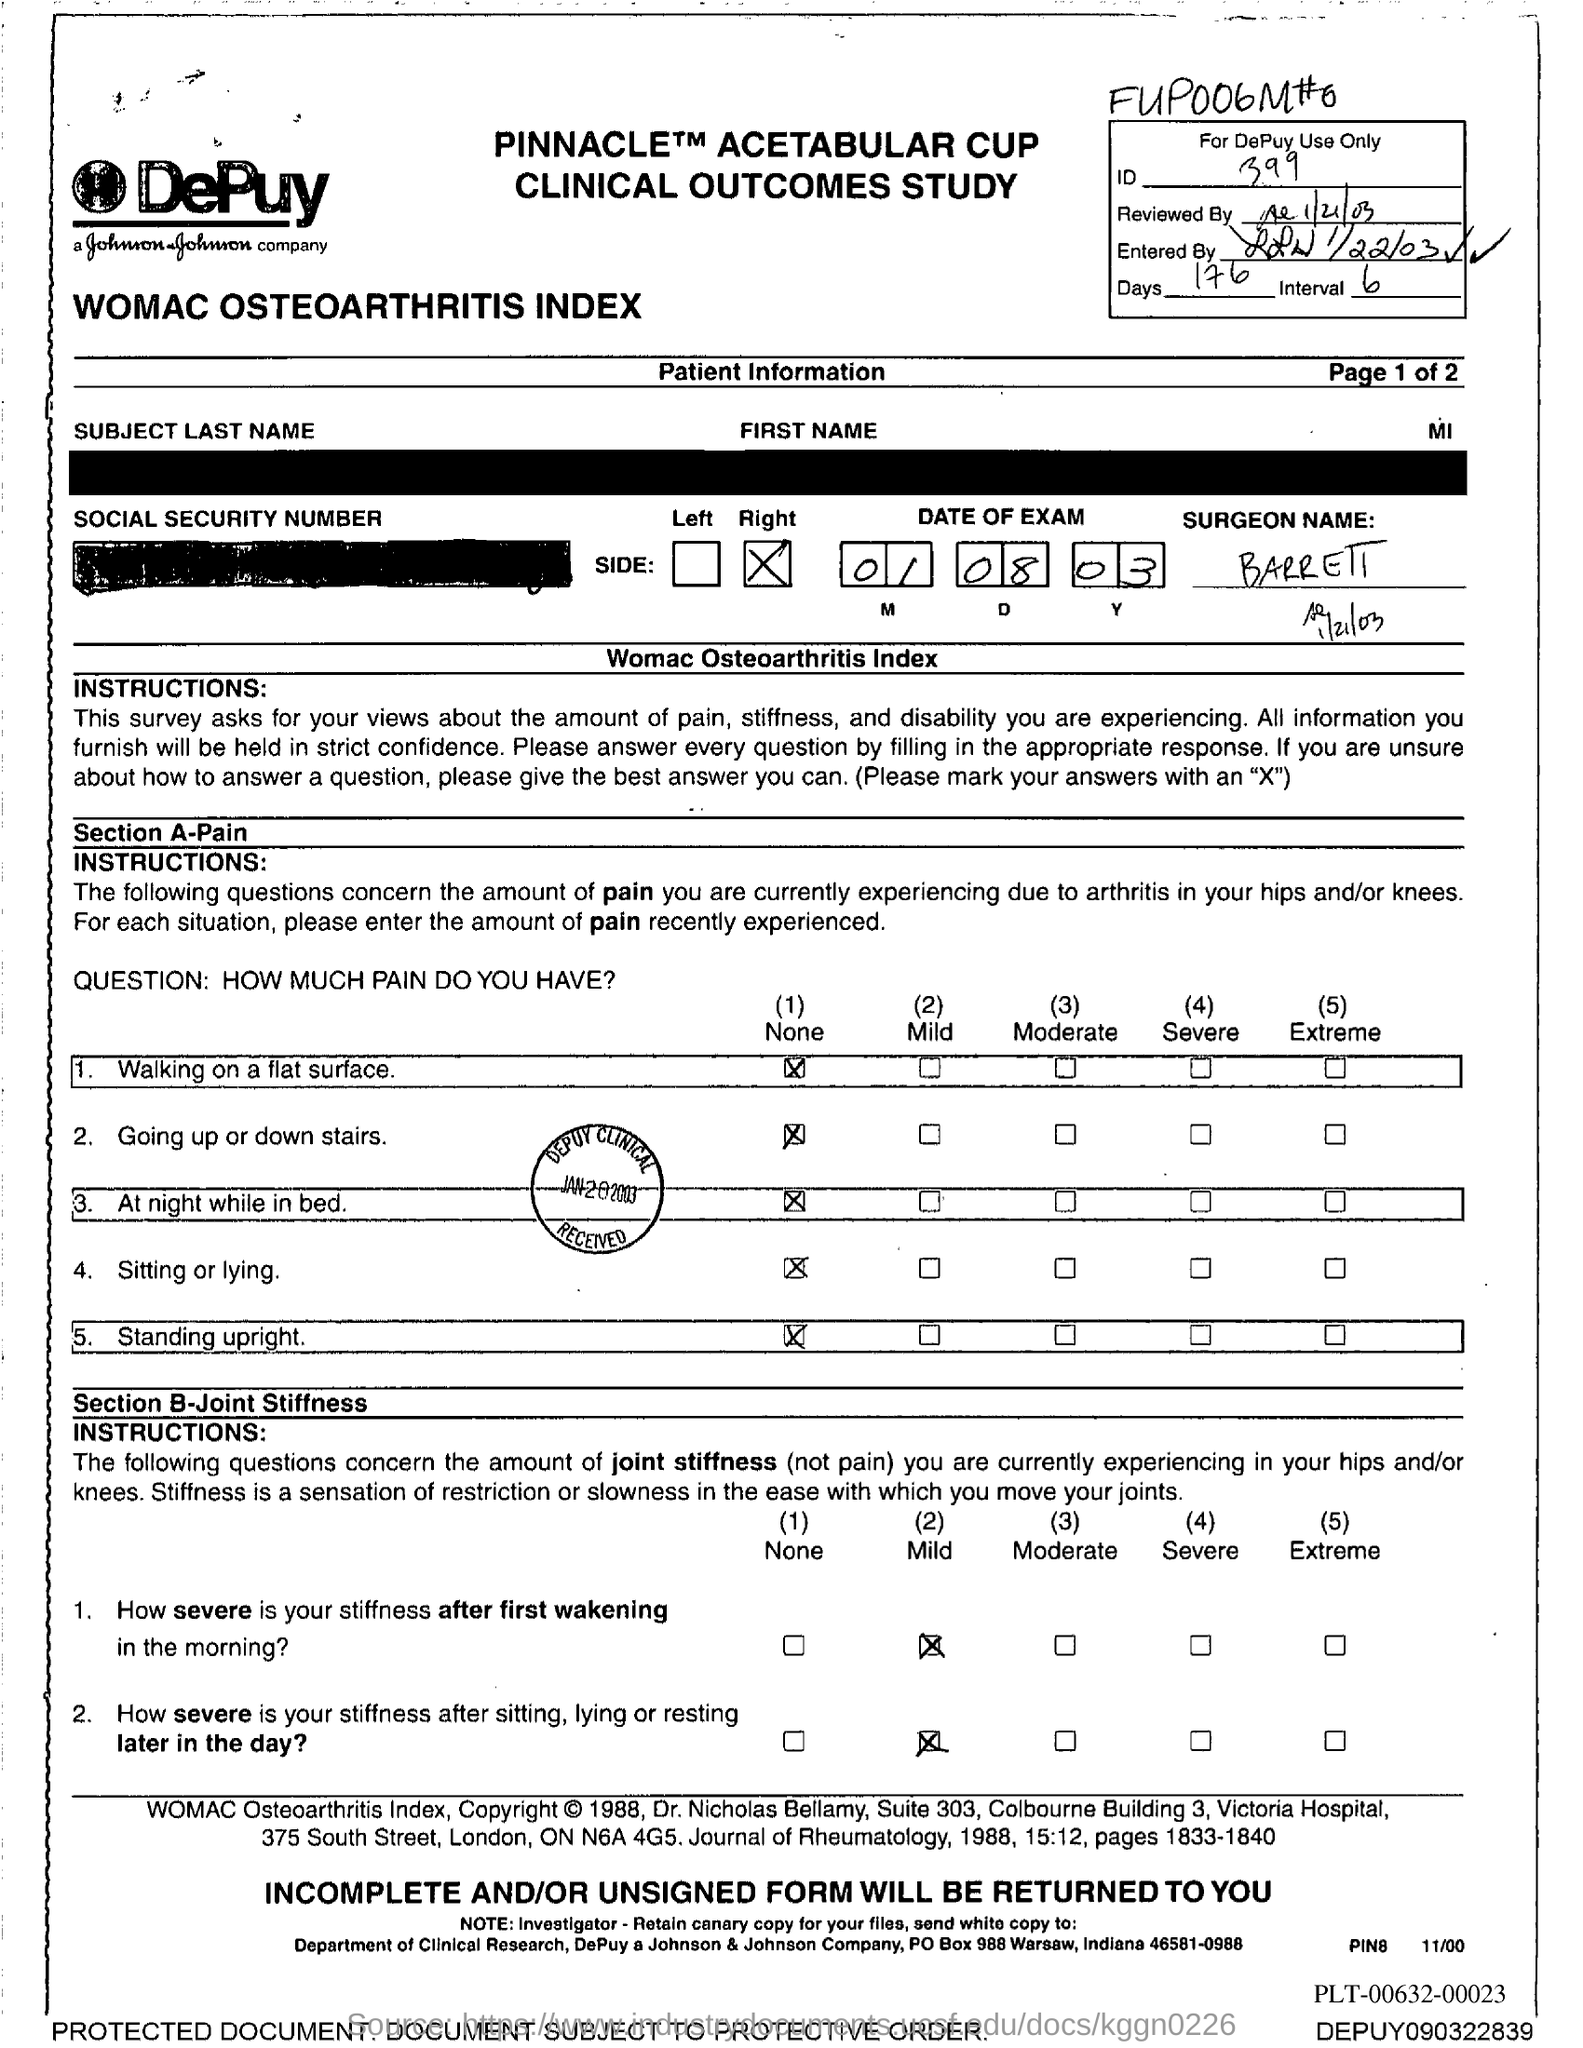What is the date of exam mentioned in the document?
Ensure brevity in your answer.  01 08 03. What is the ID given in the document?
Your answer should be very brief. 399. What is the no of days given in the document?
Make the answer very short. 176. 